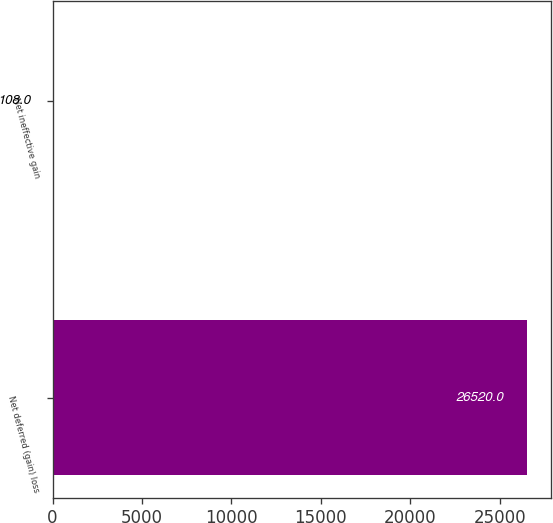<chart> <loc_0><loc_0><loc_500><loc_500><bar_chart><fcel>Net deferred (gain) loss<fcel>Net ineffective gain<nl><fcel>26520<fcel>108<nl></chart> 